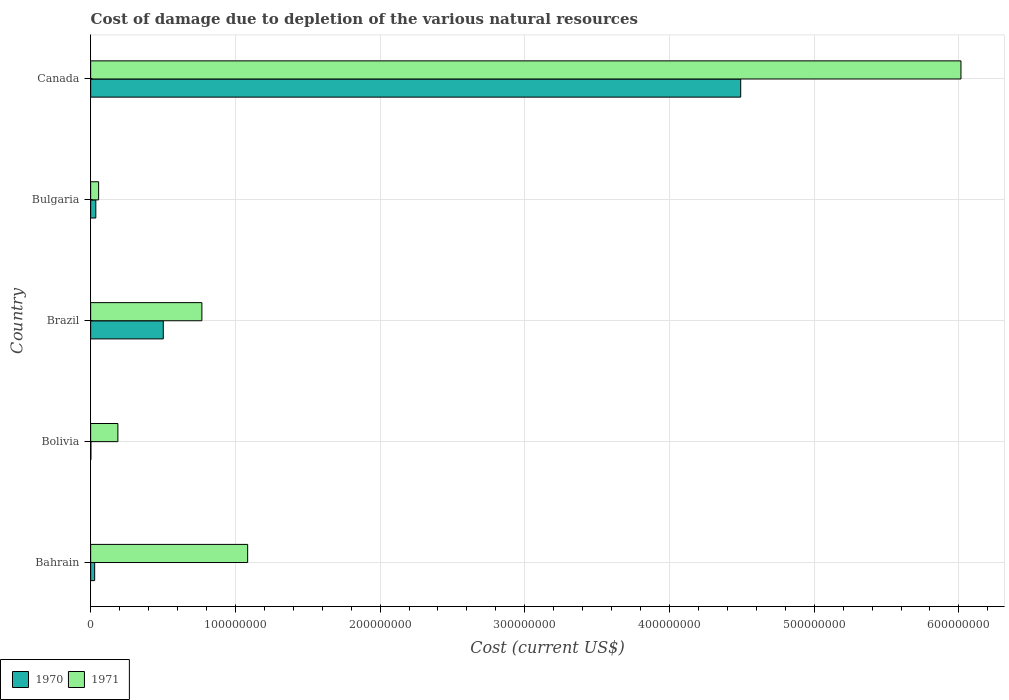How many bars are there on the 5th tick from the top?
Make the answer very short. 2. What is the cost of damage caused due to the depletion of various natural resources in 1971 in Canada?
Provide a short and direct response. 6.01e+08. Across all countries, what is the maximum cost of damage caused due to the depletion of various natural resources in 1970?
Your answer should be very brief. 4.49e+08. Across all countries, what is the minimum cost of damage caused due to the depletion of various natural resources in 1971?
Provide a succinct answer. 5.51e+06. In which country was the cost of damage caused due to the depletion of various natural resources in 1971 maximum?
Offer a terse response. Canada. In which country was the cost of damage caused due to the depletion of various natural resources in 1971 minimum?
Ensure brevity in your answer.  Bulgaria. What is the total cost of damage caused due to the depletion of various natural resources in 1970 in the graph?
Your answer should be compact. 5.06e+08. What is the difference between the cost of damage caused due to the depletion of various natural resources in 1971 in Bahrain and that in Bulgaria?
Offer a terse response. 1.03e+08. What is the difference between the cost of damage caused due to the depletion of various natural resources in 1971 in Bulgaria and the cost of damage caused due to the depletion of various natural resources in 1970 in Brazil?
Provide a succinct answer. -4.47e+07. What is the average cost of damage caused due to the depletion of various natural resources in 1970 per country?
Ensure brevity in your answer.  1.01e+08. What is the difference between the cost of damage caused due to the depletion of various natural resources in 1971 and cost of damage caused due to the depletion of various natural resources in 1970 in Bulgaria?
Your answer should be very brief. 1.95e+06. What is the ratio of the cost of damage caused due to the depletion of various natural resources in 1970 in Bulgaria to that in Canada?
Provide a short and direct response. 0.01. Is the cost of damage caused due to the depletion of various natural resources in 1971 in Bulgaria less than that in Canada?
Your response must be concise. Yes. What is the difference between the highest and the second highest cost of damage caused due to the depletion of various natural resources in 1970?
Make the answer very short. 3.99e+08. What is the difference between the highest and the lowest cost of damage caused due to the depletion of various natural resources in 1970?
Make the answer very short. 4.49e+08. Is the sum of the cost of damage caused due to the depletion of various natural resources in 1970 in Brazil and Canada greater than the maximum cost of damage caused due to the depletion of various natural resources in 1971 across all countries?
Provide a short and direct response. No. What does the 2nd bar from the bottom in Canada represents?
Ensure brevity in your answer.  1971. Are all the bars in the graph horizontal?
Your response must be concise. Yes. Does the graph contain any zero values?
Your answer should be very brief. No. How are the legend labels stacked?
Your response must be concise. Horizontal. What is the title of the graph?
Your answer should be very brief. Cost of damage due to depletion of the various natural resources. What is the label or title of the X-axis?
Give a very brief answer. Cost (current US$). What is the Cost (current US$) of 1970 in Bahrain?
Provide a succinct answer. 2.77e+06. What is the Cost (current US$) in 1971 in Bahrain?
Your answer should be very brief. 1.09e+08. What is the Cost (current US$) in 1970 in Bolivia?
Make the answer very short. 1.74e+05. What is the Cost (current US$) in 1971 in Bolivia?
Keep it short and to the point. 1.88e+07. What is the Cost (current US$) of 1970 in Brazil?
Provide a short and direct response. 5.02e+07. What is the Cost (current US$) of 1971 in Brazil?
Give a very brief answer. 7.69e+07. What is the Cost (current US$) in 1970 in Bulgaria?
Keep it short and to the point. 3.56e+06. What is the Cost (current US$) of 1971 in Bulgaria?
Your answer should be compact. 5.51e+06. What is the Cost (current US$) in 1970 in Canada?
Provide a short and direct response. 4.49e+08. What is the Cost (current US$) in 1971 in Canada?
Offer a very short reply. 6.01e+08. Across all countries, what is the maximum Cost (current US$) in 1970?
Your response must be concise. 4.49e+08. Across all countries, what is the maximum Cost (current US$) in 1971?
Provide a succinct answer. 6.01e+08. Across all countries, what is the minimum Cost (current US$) of 1970?
Provide a succinct answer. 1.74e+05. Across all countries, what is the minimum Cost (current US$) in 1971?
Offer a terse response. 5.51e+06. What is the total Cost (current US$) of 1970 in the graph?
Provide a succinct answer. 5.06e+08. What is the total Cost (current US$) of 1971 in the graph?
Keep it short and to the point. 8.11e+08. What is the difference between the Cost (current US$) of 1970 in Bahrain and that in Bolivia?
Make the answer very short. 2.60e+06. What is the difference between the Cost (current US$) of 1971 in Bahrain and that in Bolivia?
Make the answer very short. 8.97e+07. What is the difference between the Cost (current US$) in 1970 in Bahrain and that in Brazil?
Give a very brief answer. -4.74e+07. What is the difference between the Cost (current US$) in 1971 in Bahrain and that in Brazil?
Your answer should be compact. 3.16e+07. What is the difference between the Cost (current US$) in 1970 in Bahrain and that in Bulgaria?
Provide a short and direct response. -7.93e+05. What is the difference between the Cost (current US$) of 1971 in Bahrain and that in Bulgaria?
Provide a short and direct response. 1.03e+08. What is the difference between the Cost (current US$) of 1970 in Bahrain and that in Canada?
Your response must be concise. -4.46e+08. What is the difference between the Cost (current US$) of 1971 in Bahrain and that in Canada?
Offer a very short reply. -4.93e+08. What is the difference between the Cost (current US$) of 1970 in Bolivia and that in Brazil?
Offer a terse response. -5.00e+07. What is the difference between the Cost (current US$) in 1971 in Bolivia and that in Brazil?
Make the answer very short. -5.80e+07. What is the difference between the Cost (current US$) of 1970 in Bolivia and that in Bulgaria?
Give a very brief answer. -3.39e+06. What is the difference between the Cost (current US$) in 1971 in Bolivia and that in Bulgaria?
Make the answer very short. 1.33e+07. What is the difference between the Cost (current US$) of 1970 in Bolivia and that in Canada?
Your response must be concise. -4.49e+08. What is the difference between the Cost (current US$) of 1971 in Bolivia and that in Canada?
Provide a short and direct response. -5.83e+08. What is the difference between the Cost (current US$) in 1970 in Brazil and that in Bulgaria?
Your response must be concise. 4.66e+07. What is the difference between the Cost (current US$) in 1971 in Brazil and that in Bulgaria?
Your answer should be compact. 7.14e+07. What is the difference between the Cost (current US$) of 1970 in Brazil and that in Canada?
Your response must be concise. -3.99e+08. What is the difference between the Cost (current US$) in 1971 in Brazil and that in Canada?
Ensure brevity in your answer.  -5.25e+08. What is the difference between the Cost (current US$) of 1970 in Bulgaria and that in Canada?
Your answer should be compact. -4.46e+08. What is the difference between the Cost (current US$) of 1971 in Bulgaria and that in Canada?
Your answer should be compact. -5.96e+08. What is the difference between the Cost (current US$) in 1970 in Bahrain and the Cost (current US$) in 1971 in Bolivia?
Provide a succinct answer. -1.61e+07. What is the difference between the Cost (current US$) in 1970 in Bahrain and the Cost (current US$) in 1971 in Brazil?
Make the answer very short. -7.41e+07. What is the difference between the Cost (current US$) in 1970 in Bahrain and the Cost (current US$) in 1971 in Bulgaria?
Your response must be concise. -2.74e+06. What is the difference between the Cost (current US$) of 1970 in Bahrain and the Cost (current US$) of 1971 in Canada?
Your answer should be compact. -5.99e+08. What is the difference between the Cost (current US$) of 1970 in Bolivia and the Cost (current US$) of 1971 in Brazil?
Keep it short and to the point. -7.67e+07. What is the difference between the Cost (current US$) in 1970 in Bolivia and the Cost (current US$) in 1971 in Bulgaria?
Your answer should be compact. -5.33e+06. What is the difference between the Cost (current US$) of 1970 in Bolivia and the Cost (current US$) of 1971 in Canada?
Make the answer very short. -6.01e+08. What is the difference between the Cost (current US$) of 1970 in Brazil and the Cost (current US$) of 1971 in Bulgaria?
Keep it short and to the point. 4.47e+07. What is the difference between the Cost (current US$) of 1970 in Brazil and the Cost (current US$) of 1971 in Canada?
Your answer should be compact. -5.51e+08. What is the difference between the Cost (current US$) in 1970 in Bulgaria and the Cost (current US$) in 1971 in Canada?
Your answer should be very brief. -5.98e+08. What is the average Cost (current US$) in 1970 per country?
Offer a terse response. 1.01e+08. What is the average Cost (current US$) in 1971 per country?
Provide a succinct answer. 1.62e+08. What is the difference between the Cost (current US$) of 1970 and Cost (current US$) of 1971 in Bahrain?
Provide a succinct answer. -1.06e+08. What is the difference between the Cost (current US$) of 1970 and Cost (current US$) of 1971 in Bolivia?
Offer a very short reply. -1.86e+07. What is the difference between the Cost (current US$) of 1970 and Cost (current US$) of 1971 in Brazil?
Offer a very short reply. -2.67e+07. What is the difference between the Cost (current US$) in 1970 and Cost (current US$) in 1971 in Bulgaria?
Keep it short and to the point. -1.95e+06. What is the difference between the Cost (current US$) of 1970 and Cost (current US$) of 1971 in Canada?
Offer a very short reply. -1.52e+08. What is the ratio of the Cost (current US$) of 1970 in Bahrain to that in Bolivia?
Make the answer very short. 15.88. What is the ratio of the Cost (current US$) of 1971 in Bahrain to that in Bolivia?
Your answer should be compact. 5.77. What is the ratio of the Cost (current US$) of 1970 in Bahrain to that in Brazil?
Offer a terse response. 0.06. What is the ratio of the Cost (current US$) of 1971 in Bahrain to that in Brazil?
Keep it short and to the point. 1.41. What is the ratio of the Cost (current US$) in 1970 in Bahrain to that in Bulgaria?
Your answer should be compact. 0.78. What is the ratio of the Cost (current US$) of 1971 in Bahrain to that in Bulgaria?
Your answer should be compact. 19.7. What is the ratio of the Cost (current US$) of 1970 in Bahrain to that in Canada?
Provide a short and direct response. 0.01. What is the ratio of the Cost (current US$) of 1971 in Bahrain to that in Canada?
Your answer should be very brief. 0.18. What is the ratio of the Cost (current US$) in 1970 in Bolivia to that in Brazil?
Keep it short and to the point. 0. What is the ratio of the Cost (current US$) in 1971 in Bolivia to that in Brazil?
Give a very brief answer. 0.24. What is the ratio of the Cost (current US$) of 1970 in Bolivia to that in Bulgaria?
Make the answer very short. 0.05. What is the ratio of the Cost (current US$) of 1971 in Bolivia to that in Bulgaria?
Keep it short and to the point. 3.42. What is the ratio of the Cost (current US$) of 1970 in Bolivia to that in Canada?
Provide a short and direct response. 0. What is the ratio of the Cost (current US$) of 1971 in Bolivia to that in Canada?
Provide a short and direct response. 0.03. What is the ratio of the Cost (current US$) of 1970 in Brazil to that in Bulgaria?
Ensure brevity in your answer.  14.09. What is the ratio of the Cost (current US$) of 1971 in Brazil to that in Bulgaria?
Keep it short and to the point. 13.95. What is the ratio of the Cost (current US$) of 1970 in Brazil to that in Canada?
Your answer should be very brief. 0.11. What is the ratio of the Cost (current US$) in 1971 in Brazil to that in Canada?
Make the answer very short. 0.13. What is the ratio of the Cost (current US$) in 1970 in Bulgaria to that in Canada?
Your answer should be compact. 0.01. What is the ratio of the Cost (current US$) of 1971 in Bulgaria to that in Canada?
Your response must be concise. 0.01. What is the difference between the highest and the second highest Cost (current US$) of 1970?
Your response must be concise. 3.99e+08. What is the difference between the highest and the second highest Cost (current US$) of 1971?
Ensure brevity in your answer.  4.93e+08. What is the difference between the highest and the lowest Cost (current US$) of 1970?
Provide a succinct answer. 4.49e+08. What is the difference between the highest and the lowest Cost (current US$) in 1971?
Provide a short and direct response. 5.96e+08. 